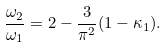Convert formula to latex. <formula><loc_0><loc_0><loc_500><loc_500>\frac { \omega _ { 2 } } { \omega _ { 1 } } = 2 - \frac { 3 } { \pi ^ { 2 } } ( 1 - \kappa _ { 1 } ) .</formula> 